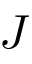<formula> <loc_0><loc_0><loc_500><loc_500>J</formula> 